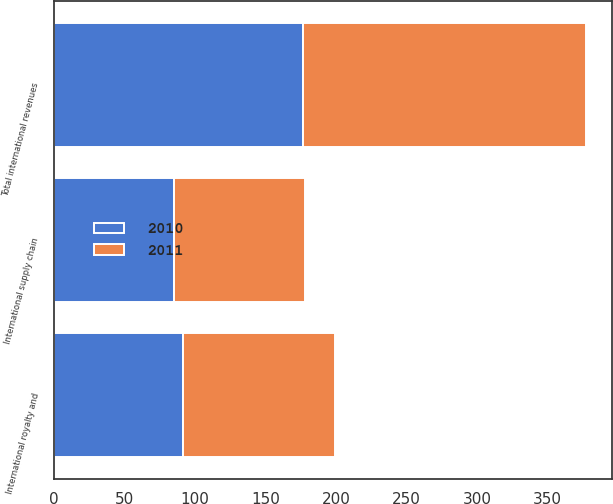Convert chart to OTSL. <chart><loc_0><loc_0><loc_500><loc_500><stacked_bar_chart><ecel><fcel>International royalty and<fcel>International supply chain<fcel>Total international revenues<nl><fcel>2010<fcel>91.3<fcel>85.1<fcel>176.4<nl><fcel>2011<fcel>107.9<fcel>93<fcel>200.9<nl></chart> 